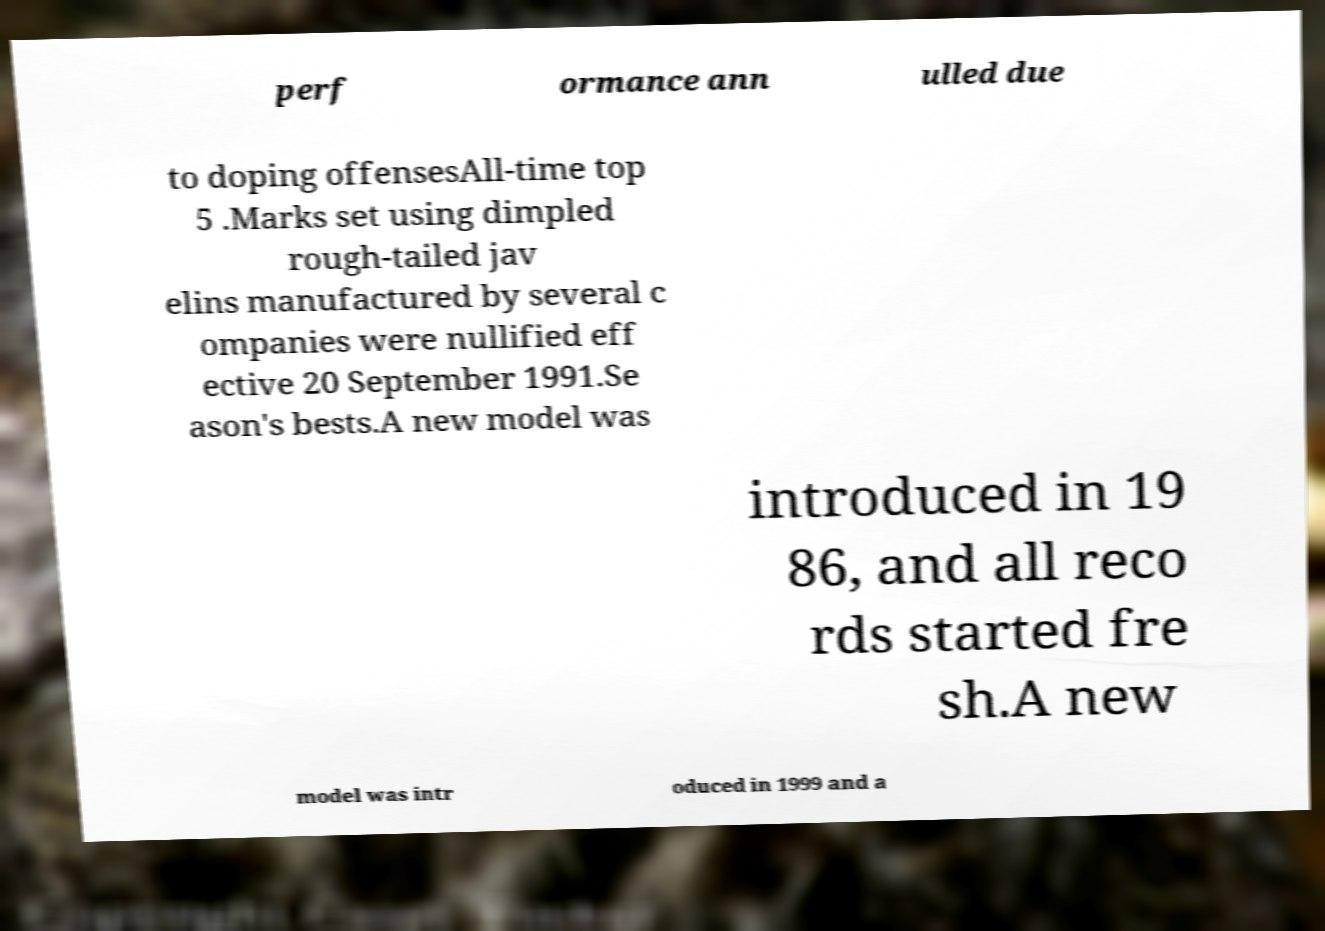There's text embedded in this image that I need extracted. Can you transcribe it verbatim? perf ormance ann ulled due to doping offensesAll-time top 5 .Marks set using dimpled rough-tailed jav elins manufactured by several c ompanies were nullified eff ective 20 September 1991.Se ason's bests.A new model was introduced in 19 86, and all reco rds started fre sh.A new model was intr oduced in 1999 and a 